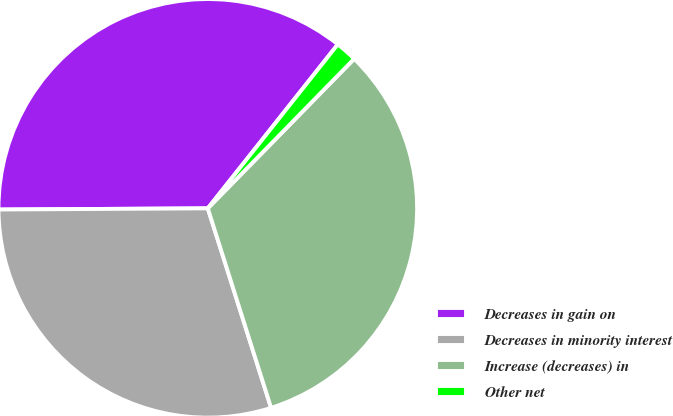<chart> <loc_0><loc_0><loc_500><loc_500><pie_chart><fcel>Decreases in gain on<fcel>Decreases in minority interest<fcel>Increase (decreases) in<fcel>Other net<nl><fcel>35.76%<fcel>29.8%<fcel>32.78%<fcel>1.66%<nl></chart> 